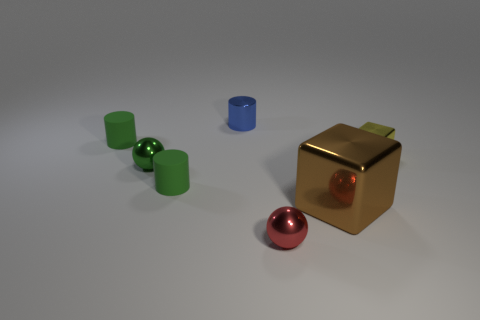How are the shadows in the image indicating the light source direction? The shadows in the image are stretched out toward the bottom left corner, indicating that the light source is coming from the upper right side, out of the frame of the image. 